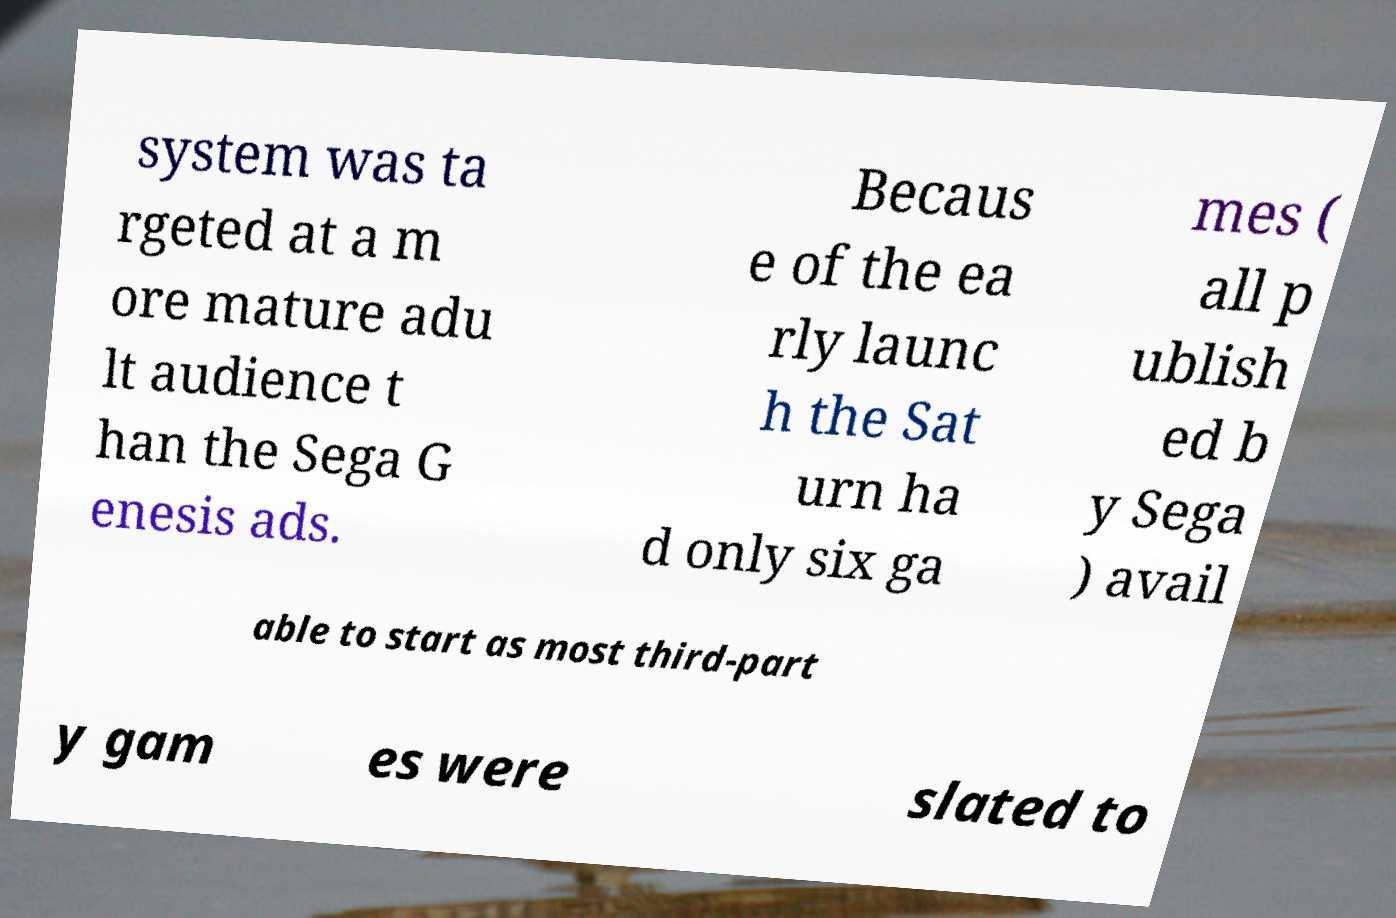For documentation purposes, I need the text within this image transcribed. Could you provide that? system was ta rgeted at a m ore mature adu lt audience t han the Sega G enesis ads. Becaus e of the ea rly launc h the Sat urn ha d only six ga mes ( all p ublish ed b y Sega ) avail able to start as most third-part y gam es were slated to 